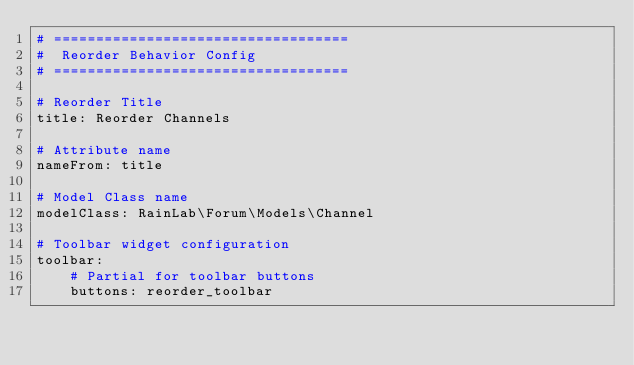Convert code to text. <code><loc_0><loc_0><loc_500><loc_500><_YAML_># ===================================
#  Reorder Behavior Config
# ===================================

# Reorder Title
title: Reorder Channels

# Attribute name
nameFrom: title

# Model Class name
modelClass: RainLab\Forum\Models\Channel

# Toolbar widget configuration
toolbar:
    # Partial for toolbar buttons
    buttons: reorder_toolbar
</code> 